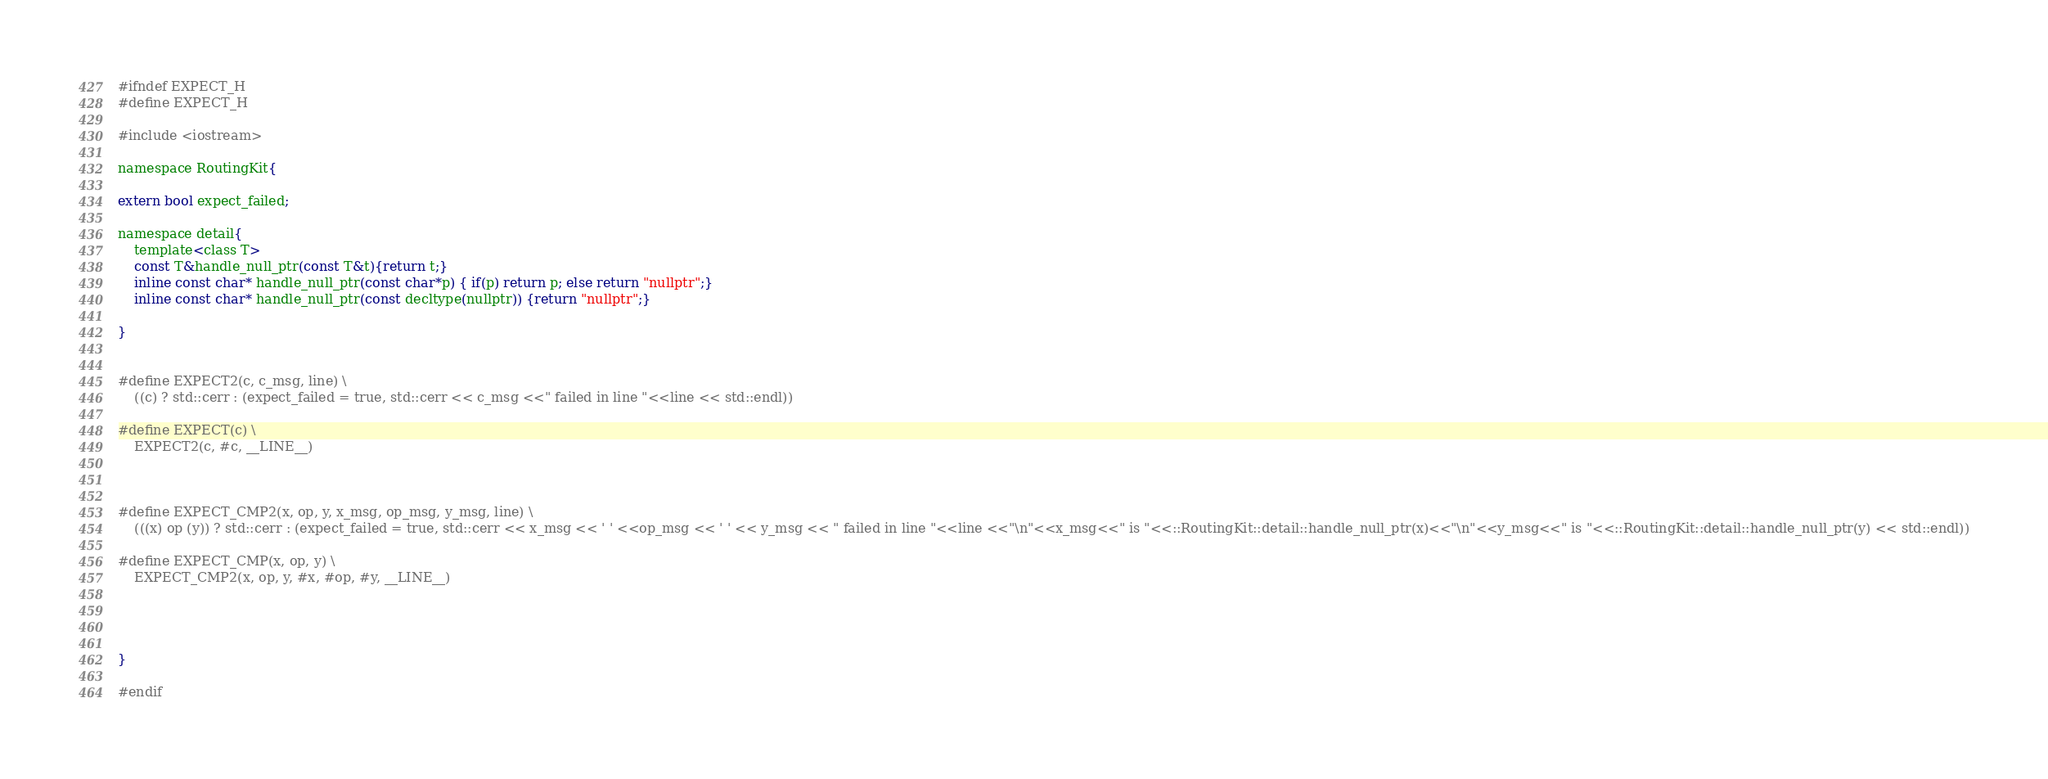<code> <loc_0><loc_0><loc_500><loc_500><_C_>#ifndef EXPECT_H
#define EXPECT_H

#include <iostream>

namespace RoutingKit{

extern bool expect_failed;

namespace detail{
	template<class T>
	const T&handle_null_ptr(const T&t){return t;}
	inline const char* handle_null_ptr(const char*p) { if(p) return p; else return "nullptr";}
	inline const char* handle_null_ptr(const decltype(nullptr)) {return "nullptr";}

}


#define EXPECT2(c, c_msg, line) \
	((c) ? std::cerr : (expect_failed = true, std::cerr << c_msg <<" failed in line "<<line << std::endl))

#define EXPECT(c) \
	EXPECT2(c, #c, __LINE__)



#define EXPECT_CMP2(x, op, y, x_msg, op_msg, y_msg, line) \
	(((x) op (y)) ? std::cerr : (expect_failed = true, std::cerr << x_msg << ' ' <<op_msg << ' ' << y_msg << " failed in line "<<line <<"\n"<<x_msg<<" is "<<::RoutingKit::detail::handle_null_ptr(x)<<"\n"<<y_msg<<" is "<<::RoutingKit::detail::handle_null_ptr(y) << std::endl))

#define EXPECT_CMP(x, op, y) \
	EXPECT_CMP2(x, op, y, #x, #op, #y, __LINE__)




}

#endif
</code> 